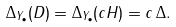<formula> <loc_0><loc_0><loc_500><loc_500>\Delta _ { Y _ { \bullet } } ( D ) = \Delta _ { Y _ { \bullet } } ( c H ) = c \, \Delta .</formula> 